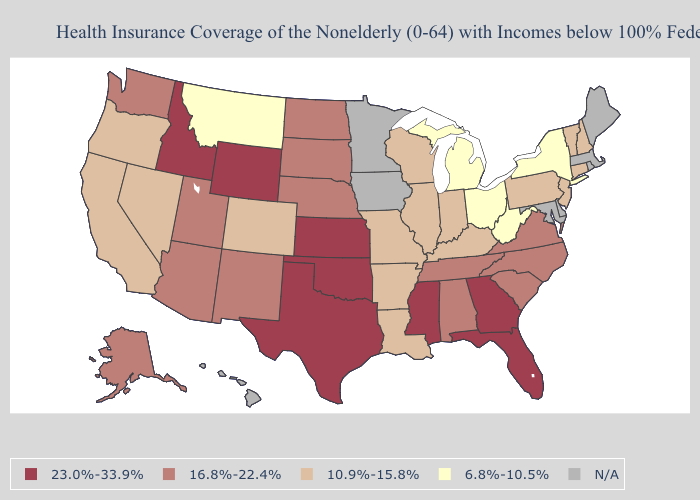Does Virginia have the highest value in the USA?
Answer briefly. No. Name the states that have a value in the range N/A?
Short answer required. Delaware, Hawaii, Iowa, Maine, Maryland, Massachusetts, Minnesota, Rhode Island. What is the value of Ohio?
Be succinct. 6.8%-10.5%. Name the states that have a value in the range 23.0%-33.9%?
Be succinct. Florida, Georgia, Idaho, Kansas, Mississippi, Oklahoma, Texas, Wyoming. What is the value of Colorado?
Write a very short answer. 10.9%-15.8%. Does West Virginia have the lowest value in the USA?
Answer briefly. Yes. What is the value of Florida?
Write a very short answer. 23.0%-33.9%. What is the highest value in states that border Illinois?
Keep it brief. 10.9%-15.8%. Name the states that have a value in the range 23.0%-33.9%?
Answer briefly. Florida, Georgia, Idaho, Kansas, Mississippi, Oklahoma, Texas, Wyoming. What is the lowest value in states that border Delaware?
Give a very brief answer. 10.9%-15.8%. Among the states that border South Carolina , which have the highest value?
Quick response, please. Georgia. Does the map have missing data?
Give a very brief answer. Yes. What is the value of Kentucky?
Concise answer only. 10.9%-15.8%. Does Oregon have the highest value in the West?
Give a very brief answer. No. 